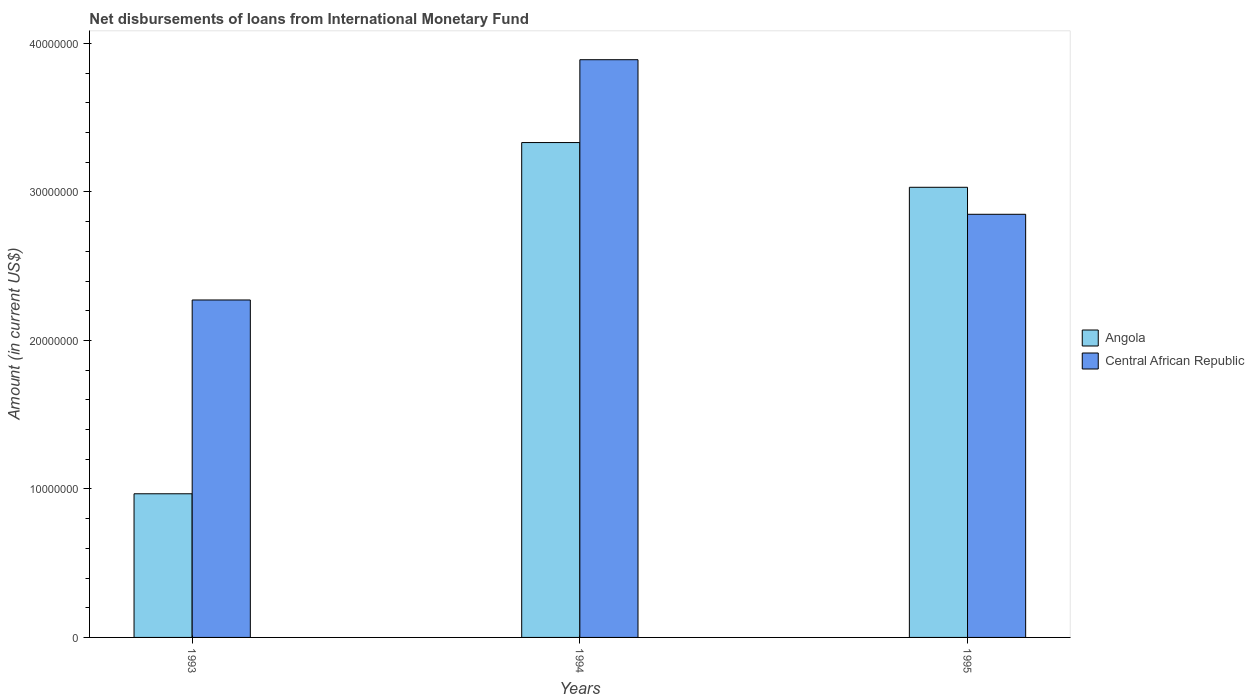How many different coloured bars are there?
Offer a terse response. 2. How many bars are there on the 2nd tick from the left?
Your answer should be very brief. 2. How many bars are there on the 3rd tick from the right?
Your response must be concise. 2. What is the label of the 2nd group of bars from the left?
Give a very brief answer. 1994. What is the amount of loans disbursed in Central African Republic in 1993?
Make the answer very short. 2.27e+07. Across all years, what is the maximum amount of loans disbursed in Angola?
Keep it short and to the point. 3.33e+07. Across all years, what is the minimum amount of loans disbursed in Central African Republic?
Offer a very short reply. 2.27e+07. What is the total amount of loans disbursed in Central African Republic in the graph?
Your response must be concise. 9.01e+07. What is the difference between the amount of loans disbursed in Angola in 1993 and that in 1995?
Ensure brevity in your answer.  -2.06e+07. What is the difference between the amount of loans disbursed in Angola in 1993 and the amount of loans disbursed in Central African Republic in 1995?
Ensure brevity in your answer.  -1.88e+07. What is the average amount of loans disbursed in Central African Republic per year?
Provide a short and direct response. 3.00e+07. In the year 1995, what is the difference between the amount of loans disbursed in Central African Republic and amount of loans disbursed in Angola?
Provide a succinct answer. -1.82e+06. In how many years, is the amount of loans disbursed in Angola greater than 30000000 US$?
Your response must be concise. 2. What is the ratio of the amount of loans disbursed in Central African Republic in 1994 to that in 1995?
Your response must be concise. 1.37. Is the amount of loans disbursed in Angola in 1994 less than that in 1995?
Provide a short and direct response. No. What is the difference between the highest and the second highest amount of loans disbursed in Central African Republic?
Your response must be concise. 1.04e+07. What is the difference between the highest and the lowest amount of loans disbursed in Central African Republic?
Ensure brevity in your answer.  1.62e+07. Is the sum of the amount of loans disbursed in Angola in 1993 and 1994 greater than the maximum amount of loans disbursed in Central African Republic across all years?
Make the answer very short. Yes. What does the 1st bar from the left in 1993 represents?
Keep it short and to the point. Angola. What does the 2nd bar from the right in 1995 represents?
Offer a very short reply. Angola. Are all the bars in the graph horizontal?
Ensure brevity in your answer.  No. What is the difference between two consecutive major ticks on the Y-axis?
Offer a terse response. 1.00e+07. Does the graph contain any zero values?
Offer a terse response. No. Does the graph contain grids?
Your response must be concise. No. Where does the legend appear in the graph?
Provide a succinct answer. Center right. How many legend labels are there?
Your response must be concise. 2. What is the title of the graph?
Ensure brevity in your answer.  Net disbursements of loans from International Monetary Fund. What is the label or title of the Y-axis?
Offer a very short reply. Amount (in current US$). What is the Amount (in current US$) in Angola in 1993?
Offer a terse response. 9.67e+06. What is the Amount (in current US$) of Central African Republic in 1993?
Keep it short and to the point. 2.27e+07. What is the Amount (in current US$) of Angola in 1994?
Provide a succinct answer. 3.33e+07. What is the Amount (in current US$) in Central African Republic in 1994?
Give a very brief answer. 3.89e+07. What is the Amount (in current US$) of Angola in 1995?
Offer a very short reply. 3.03e+07. What is the Amount (in current US$) in Central African Republic in 1995?
Keep it short and to the point. 2.85e+07. Across all years, what is the maximum Amount (in current US$) of Angola?
Your answer should be very brief. 3.33e+07. Across all years, what is the maximum Amount (in current US$) in Central African Republic?
Provide a short and direct response. 3.89e+07. Across all years, what is the minimum Amount (in current US$) in Angola?
Your response must be concise. 9.67e+06. Across all years, what is the minimum Amount (in current US$) of Central African Republic?
Your answer should be very brief. 2.27e+07. What is the total Amount (in current US$) of Angola in the graph?
Ensure brevity in your answer.  7.33e+07. What is the total Amount (in current US$) in Central African Republic in the graph?
Provide a short and direct response. 9.01e+07. What is the difference between the Amount (in current US$) in Angola in 1993 and that in 1994?
Make the answer very short. -2.37e+07. What is the difference between the Amount (in current US$) in Central African Republic in 1993 and that in 1994?
Your response must be concise. -1.62e+07. What is the difference between the Amount (in current US$) of Angola in 1993 and that in 1995?
Provide a short and direct response. -2.06e+07. What is the difference between the Amount (in current US$) in Central African Republic in 1993 and that in 1995?
Keep it short and to the point. -5.77e+06. What is the difference between the Amount (in current US$) in Angola in 1994 and that in 1995?
Give a very brief answer. 3.01e+06. What is the difference between the Amount (in current US$) in Central African Republic in 1994 and that in 1995?
Your answer should be very brief. 1.04e+07. What is the difference between the Amount (in current US$) in Angola in 1993 and the Amount (in current US$) in Central African Republic in 1994?
Your response must be concise. -2.92e+07. What is the difference between the Amount (in current US$) of Angola in 1993 and the Amount (in current US$) of Central African Republic in 1995?
Offer a terse response. -1.88e+07. What is the difference between the Amount (in current US$) of Angola in 1994 and the Amount (in current US$) of Central African Republic in 1995?
Your response must be concise. 4.83e+06. What is the average Amount (in current US$) in Angola per year?
Your answer should be compact. 2.44e+07. What is the average Amount (in current US$) in Central African Republic per year?
Offer a terse response. 3.00e+07. In the year 1993, what is the difference between the Amount (in current US$) in Angola and Amount (in current US$) in Central African Republic?
Give a very brief answer. -1.30e+07. In the year 1994, what is the difference between the Amount (in current US$) of Angola and Amount (in current US$) of Central African Republic?
Give a very brief answer. -5.58e+06. In the year 1995, what is the difference between the Amount (in current US$) of Angola and Amount (in current US$) of Central African Republic?
Give a very brief answer. 1.82e+06. What is the ratio of the Amount (in current US$) of Angola in 1993 to that in 1994?
Provide a succinct answer. 0.29. What is the ratio of the Amount (in current US$) in Central African Republic in 1993 to that in 1994?
Make the answer very short. 0.58. What is the ratio of the Amount (in current US$) in Angola in 1993 to that in 1995?
Provide a short and direct response. 0.32. What is the ratio of the Amount (in current US$) in Central African Republic in 1993 to that in 1995?
Your response must be concise. 0.8. What is the ratio of the Amount (in current US$) of Angola in 1994 to that in 1995?
Offer a terse response. 1.1. What is the ratio of the Amount (in current US$) of Central African Republic in 1994 to that in 1995?
Keep it short and to the point. 1.37. What is the difference between the highest and the second highest Amount (in current US$) of Angola?
Keep it short and to the point. 3.01e+06. What is the difference between the highest and the second highest Amount (in current US$) in Central African Republic?
Keep it short and to the point. 1.04e+07. What is the difference between the highest and the lowest Amount (in current US$) of Angola?
Offer a very short reply. 2.37e+07. What is the difference between the highest and the lowest Amount (in current US$) in Central African Republic?
Offer a very short reply. 1.62e+07. 